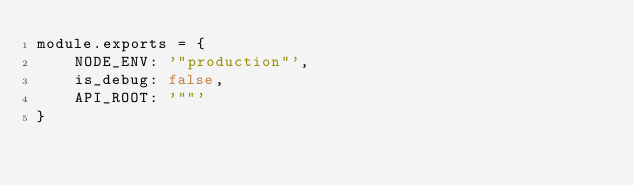Convert code to text. <code><loc_0><loc_0><loc_500><loc_500><_JavaScript_>module.exports = {
	NODE_ENV: '"production"',
	is_debug: false,
	API_ROOT: '""'
}
</code> 